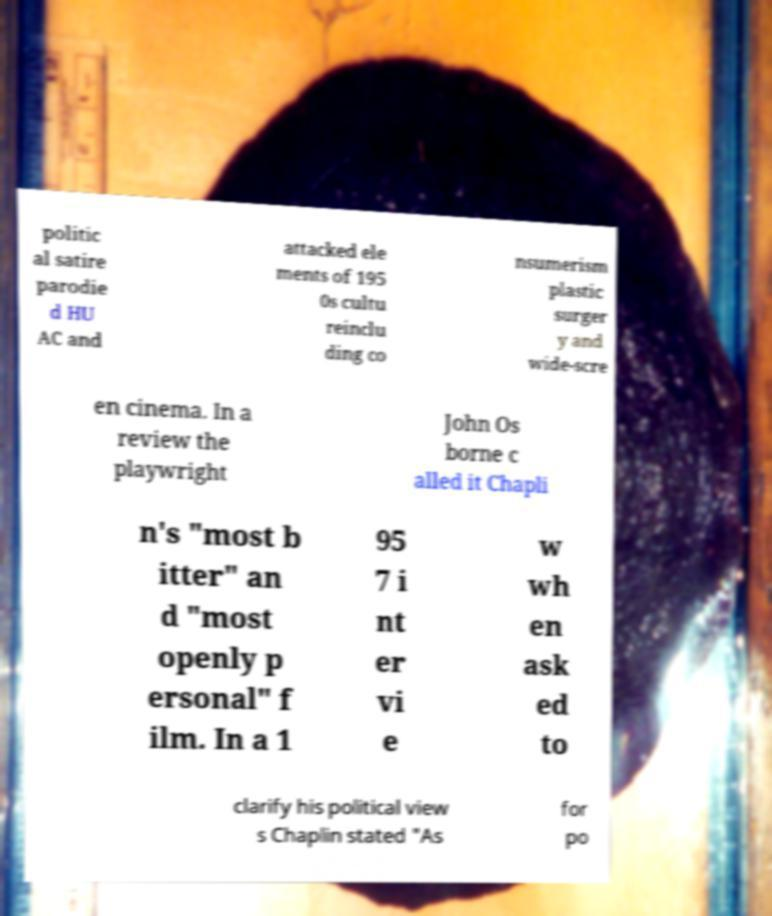Could you extract and type out the text from this image? politic al satire parodie d HU AC and attacked ele ments of 195 0s cultu reinclu ding co nsumerism plastic surger y and wide-scre en cinema. In a review the playwright John Os borne c alled it Chapli n's "most b itter" an d "most openly p ersonal" f ilm. In a 1 95 7 i nt er vi e w wh en ask ed to clarify his political view s Chaplin stated "As for po 